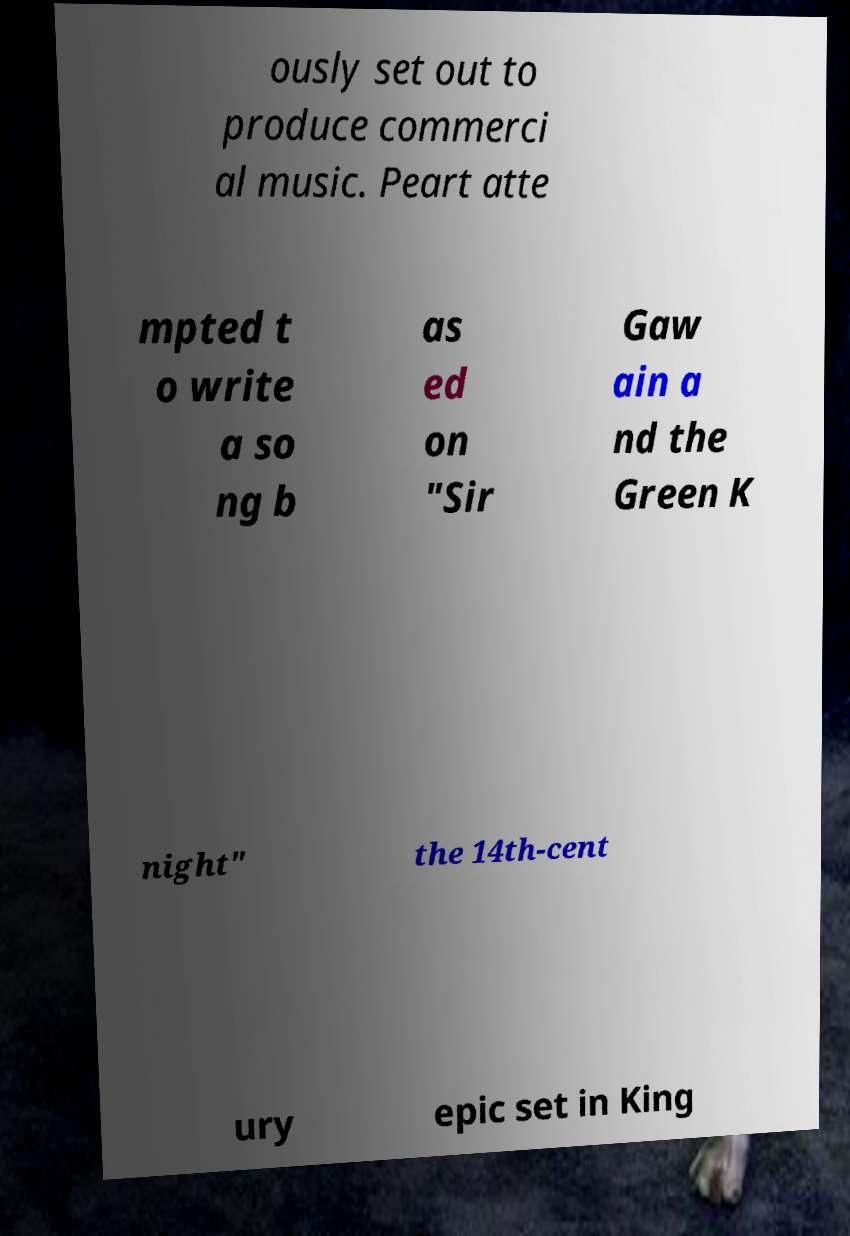There's text embedded in this image that I need extracted. Can you transcribe it verbatim? ously set out to produce commerci al music. Peart atte mpted t o write a so ng b as ed on "Sir Gaw ain a nd the Green K night" the 14th-cent ury epic set in King 